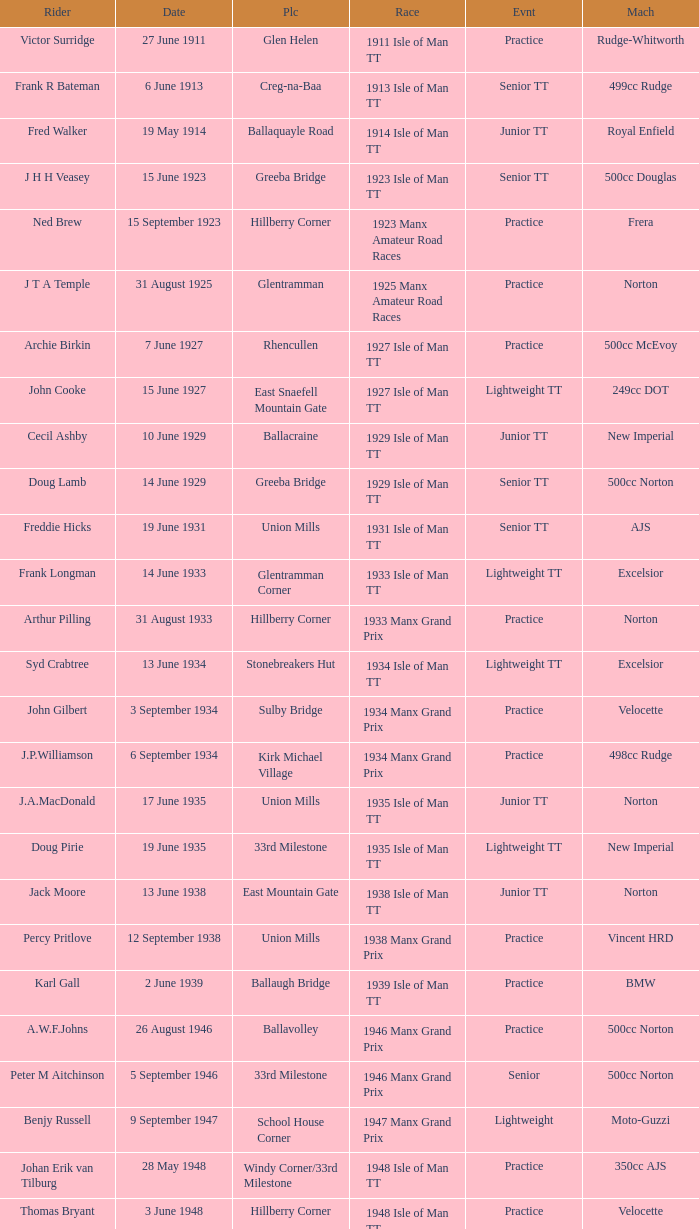What event was Rob Vine riding? Senior TT. 